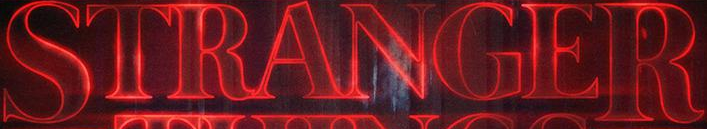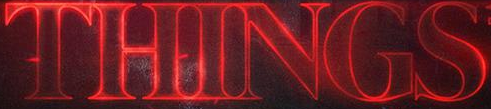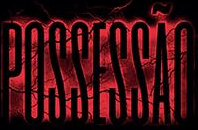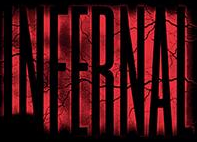What words can you see in these images in sequence, separated by a semicolon? STRANGER; THINGS; POSSESSÃO; INFERNAL 